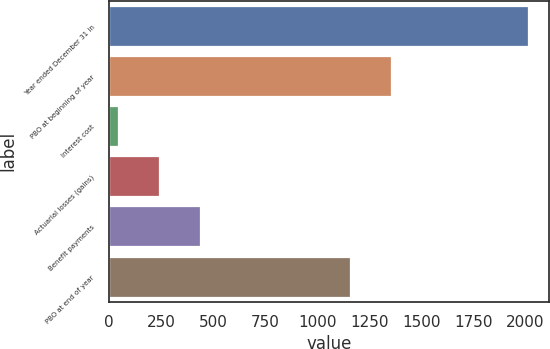Convert chart to OTSL. <chart><loc_0><loc_0><loc_500><loc_500><bar_chart><fcel>Year ended December 31 in<fcel>PBO at beginning of year<fcel>Interest cost<fcel>Actuarial losses (gains)<fcel>Benefit payments<fcel>PBO at end of year<nl><fcel>2013<fcel>1353.1<fcel>42<fcel>239.1<fcel>436.2<fcel>1156<nl></chart> 